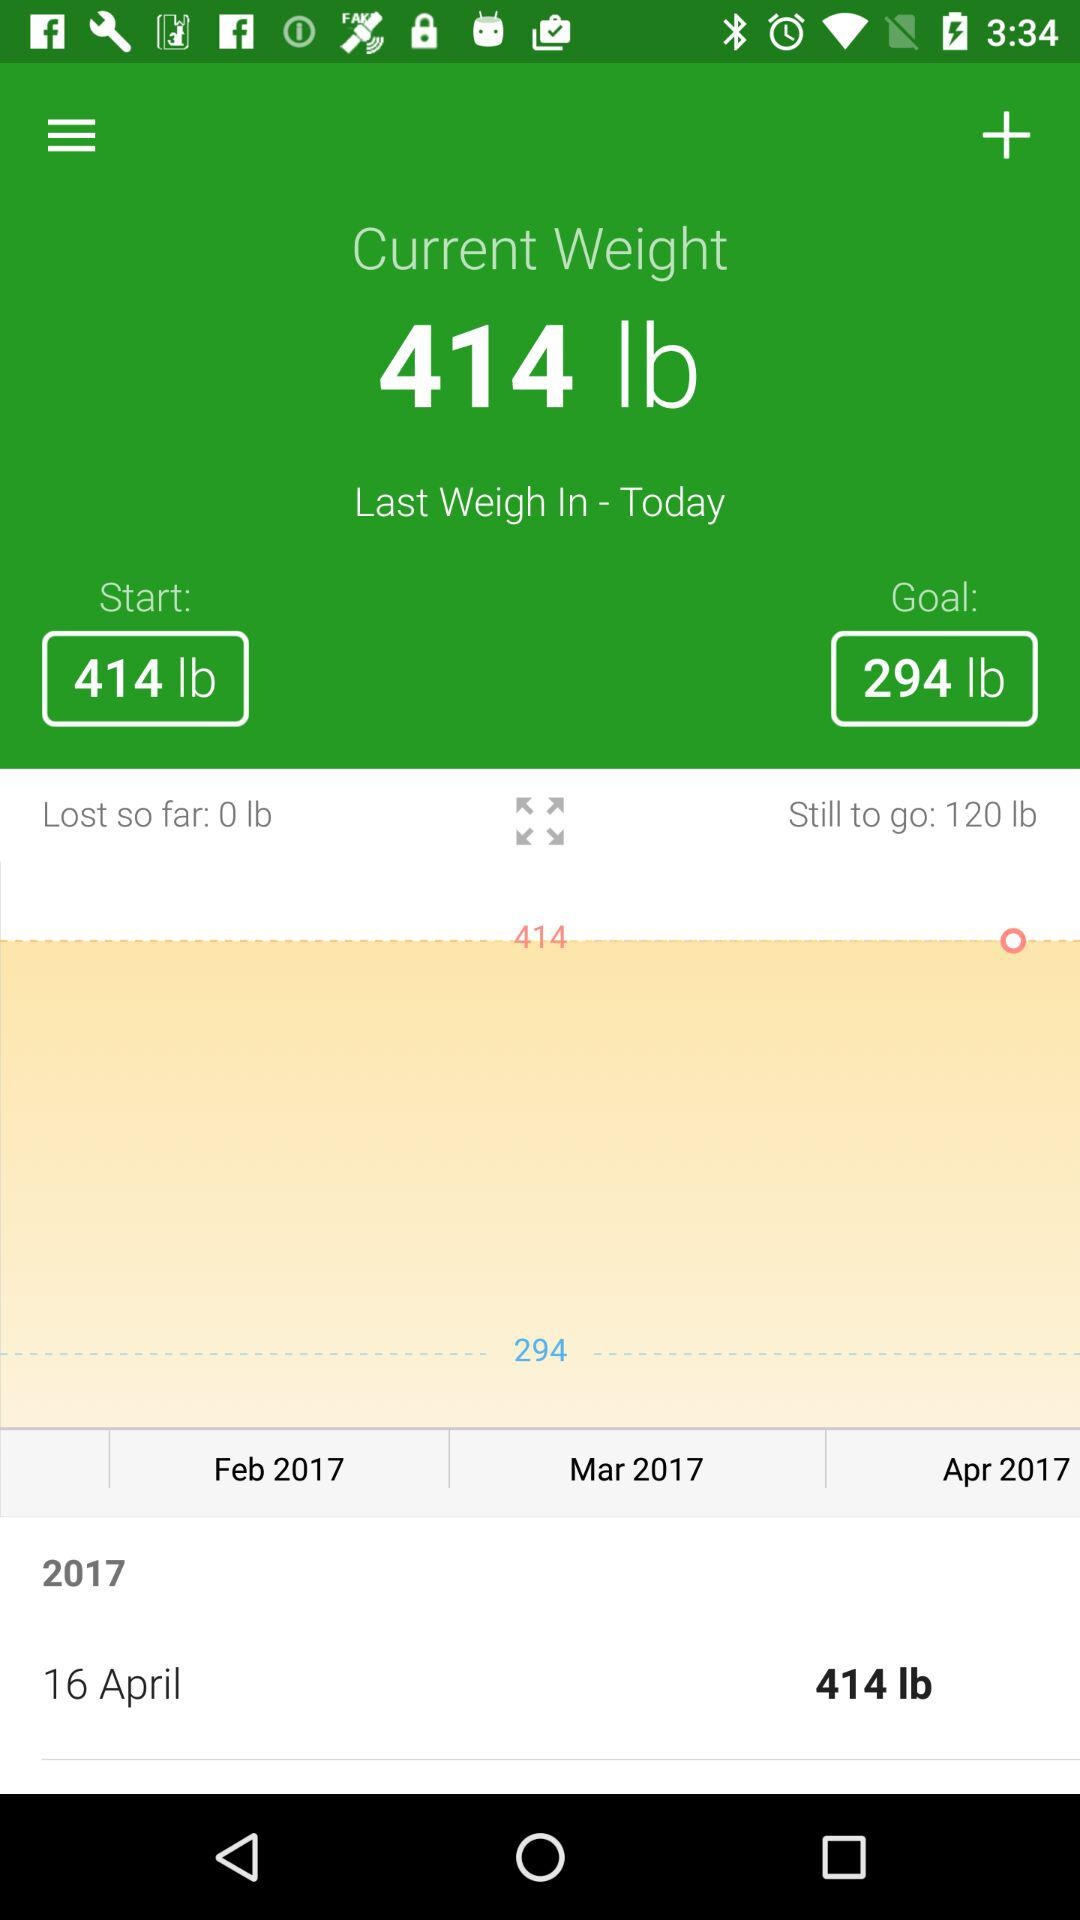How much weight has the user lost so far?
Answer the question using a single word or phrase. 0 lb 